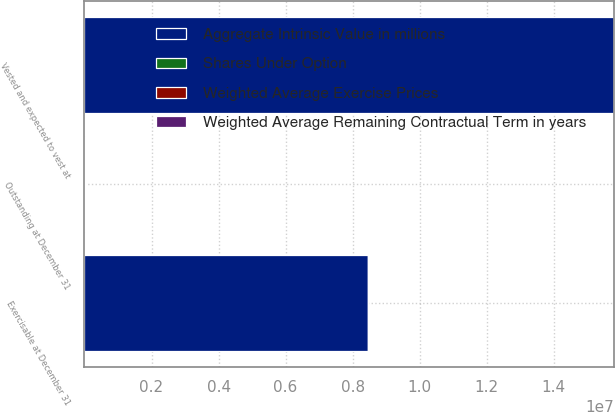<chart> <loc_0><loc_0><loc_500><loc_500><stacked_bar_chart><ecel><fcel>Outstanding at December 31<fcel>Vested and expected to vest at<fcel>Exercisable at December 31<nl><fcel>Aggregate Intrinsic Value in millions<fcel>49.73<fcel>1.57897e+07<fcel>8.46878e+06<nl><fcel>Weighted Average Exercise Prices<fcel>49.73<fcel>49.57<fcel>42.08<nl><fcel>Weighted Average Remaining Contractual Term in years<fcel>2.8<fcel>2.8<fcel>1.9<nl><fcel>Shares Under Option<fcel>396<fcel>391<fcel>273<nl></chart> 